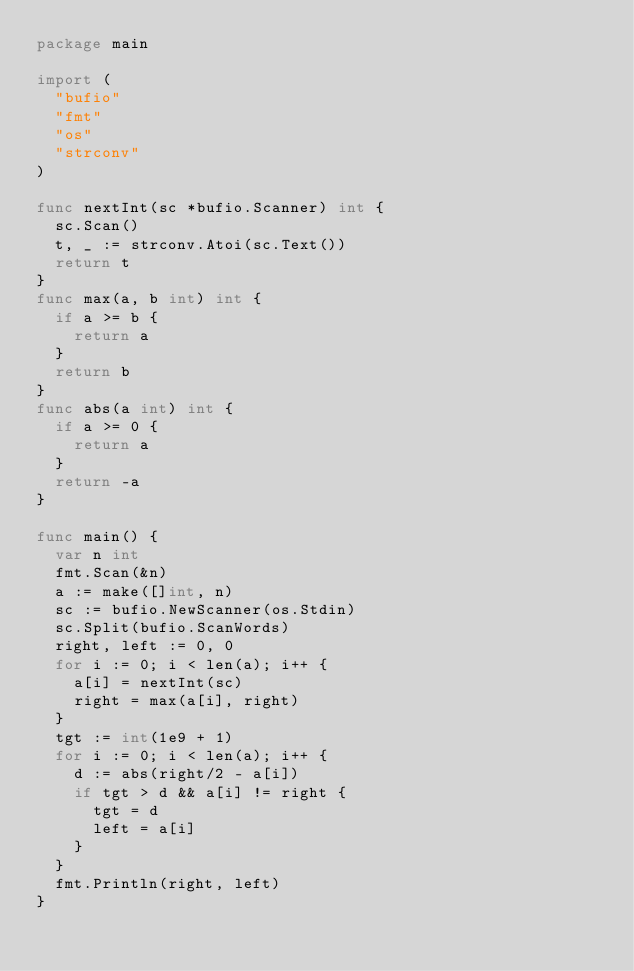<code> <loc_0><loc_0><loc_500><loc_500><_Go_>package main

import (
	"bufio"
	"fmt"
	"os"
	"strconv"
)

func nextInt(sc *bufio.Scanner) int {
	sc.Scan()
	t, _ := strconv.Atoi(sc.Text())
	return t
}
func max(a, b int) int {
	if a >= b {
		return a
	}
	return b
}
func abs(a int) int {
	if a >= 0 {
		return a
	}
	return -a
}

func main() {
	var n int
	fmt.Scan(&n)
	a := make([]int, n)
	sc := bufio.NewScanner(os.Stdin)
	sc.Split(bufio.ScanWords)
	right, left := 0, 0
	for i := 0; i < len(a); i++ {
		a[i] = nextInt(sc)
		right = max(a[i], right)
	}
	tgt := int(1e9 + 1)
	for i := 0; i < len(a); i++ {
		d := abs(right/2 - a[i])
		if tgt > d && a[i] != right {
			tgt = d
			left = a[i]
		}
	}
	fmt.Println(right, left)
}
</code> 